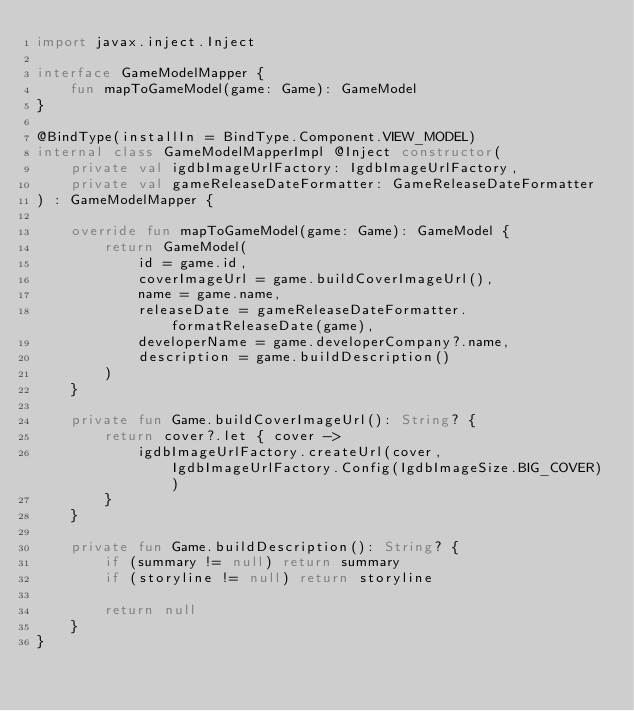<code> <loc_0><loc_0><loc_500><loc_500><_Kotlin_>import javax.inject.Inject

interface GameModelMapper {
    fun mapToGameModel(game: Game): GameModel
}

@BindType(installIn = BindType.Component.VIEW_MODEL)
internal class GameModelMapperImpl @Inject constructor(
    private val igdbImageUrlFactory: IgdbImageUrlFactory,
    private val gameReleaseDateFormatter: GameReleaseDateFormatter
) : GameModelMapper {

    override fun mapToGameModel(game: Game): GameModel {
        return GameModel(
            id = game.id,
            coverImageUrl = game.buildCoverImageUrl(),
            name = game.name,
            releaseDate = gameReleaseDateFormatter.formatReleaseDate(game),
            developerName = game.developerCompany?.name,
            description = game.buildDescription()
        )
    }

    private fun Game.buildCoverImageUrl(): String? {
        return cover?.let { cover ->
            igdbImageUrlFactory.createUrl(cover, IgdbImageUrlFactory.Config(IgdbImageSize.BIG_COVER))
        }
    }

    private fun Game.buildDescription(): String? {
        if (summary != null) return summary
        if (storyline != null) return storyline

        return null
    }
}
</code> 